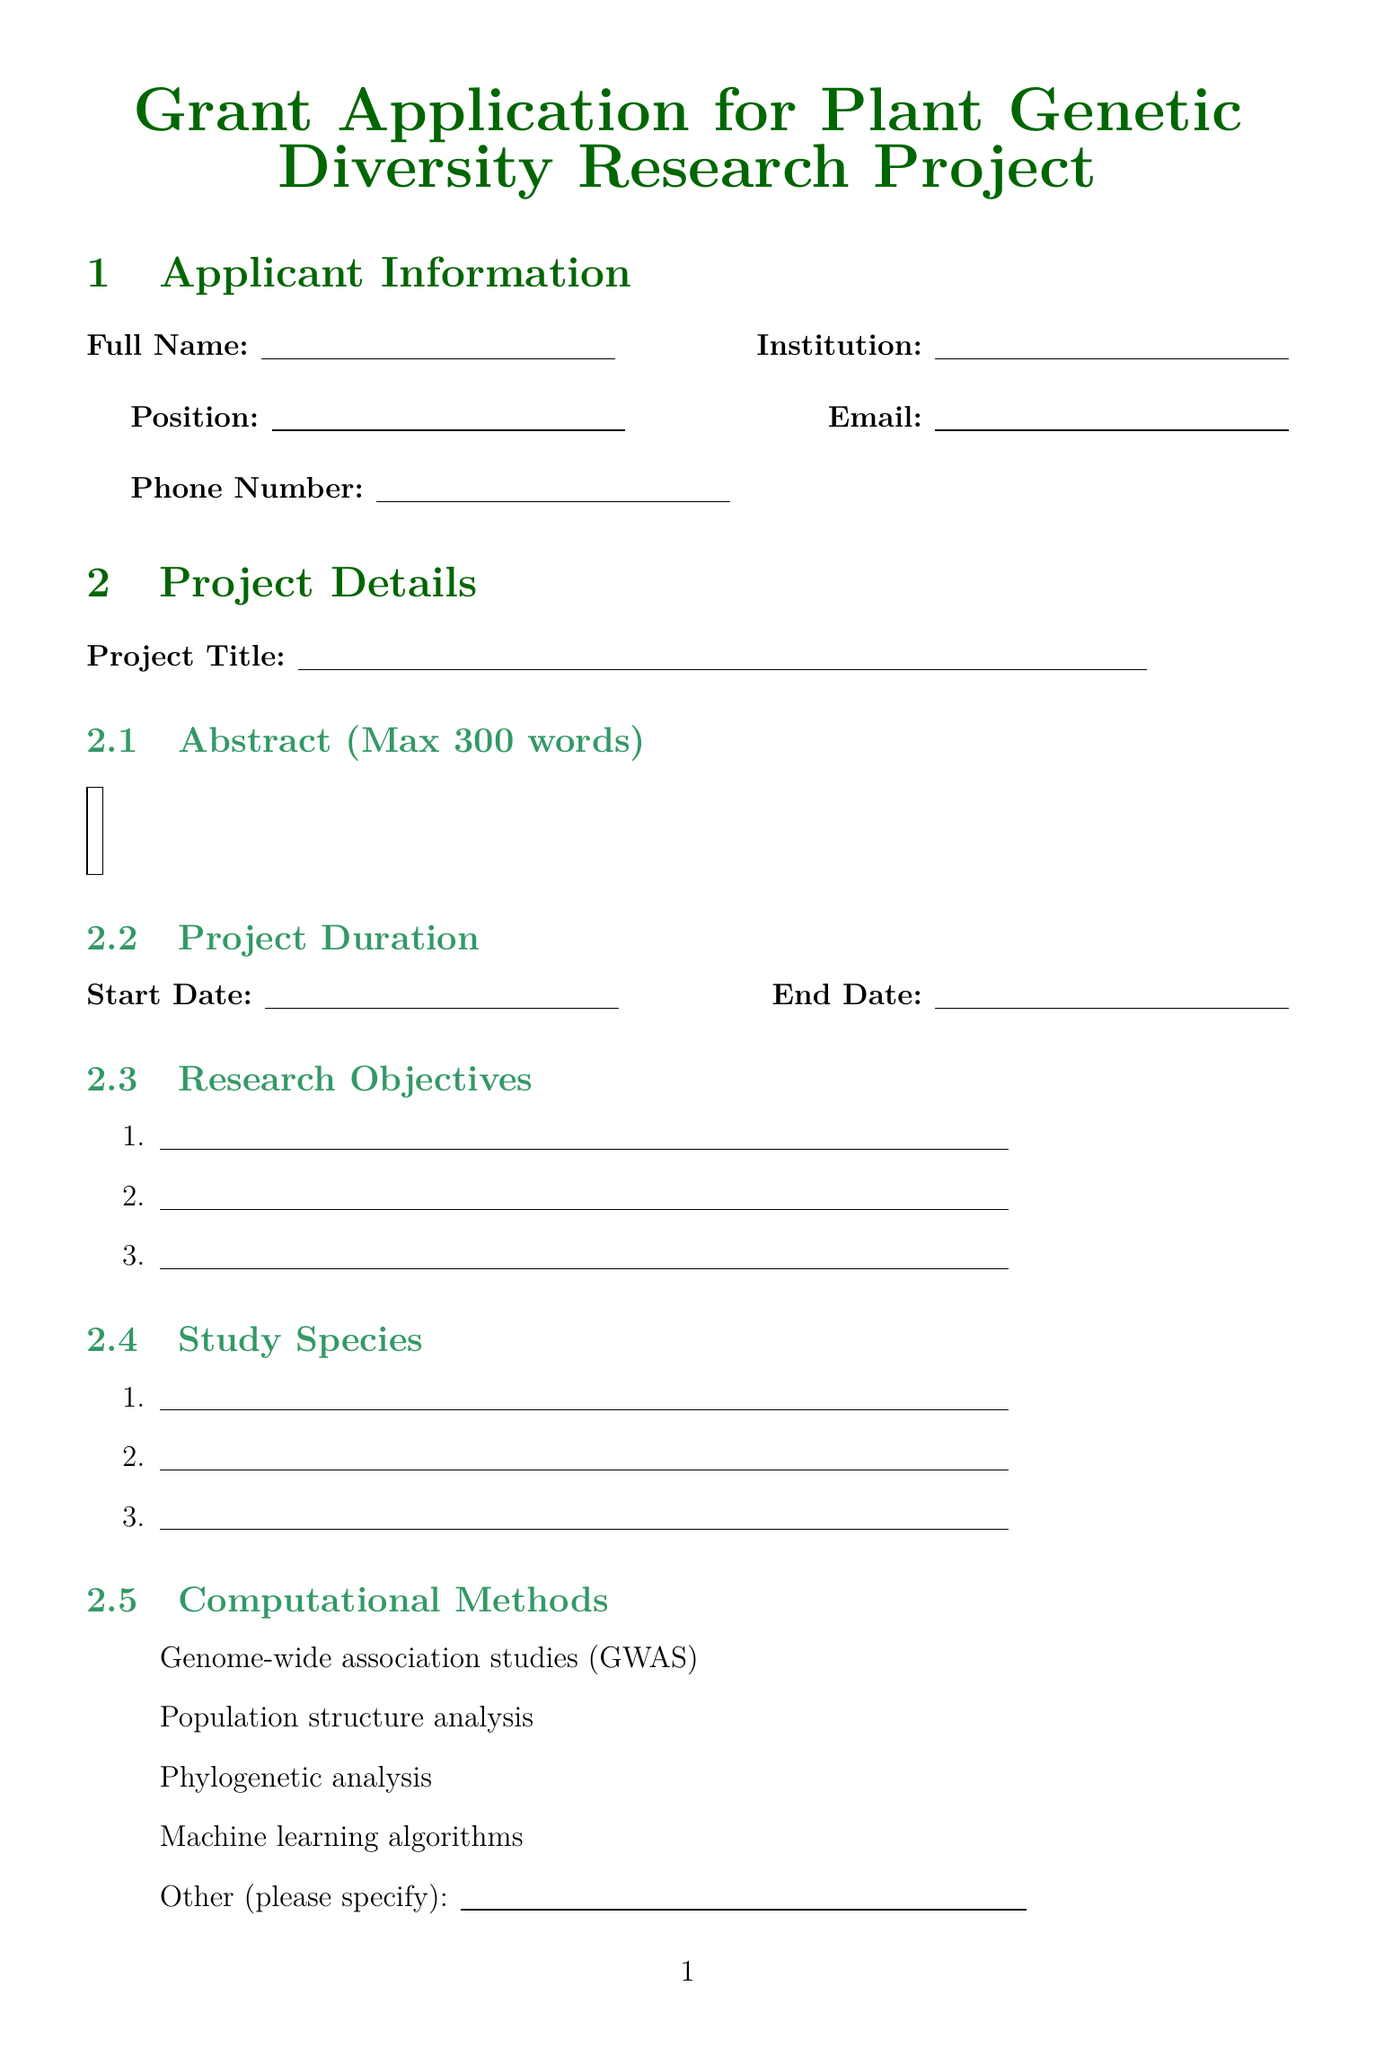What is the maximum word count for the abstract? The abstract is limited to a maximum of 300 words, as stated in the document.
Answer: 300 words Which agencies are listed for funding? The funding agencies specified in the document serve as potential sources of funding for the proposed research project.
Answer: National Science Foundation, European Research Council, Gordon and Betty Moore Foundation, Bill & Melinda Gates Foundation 